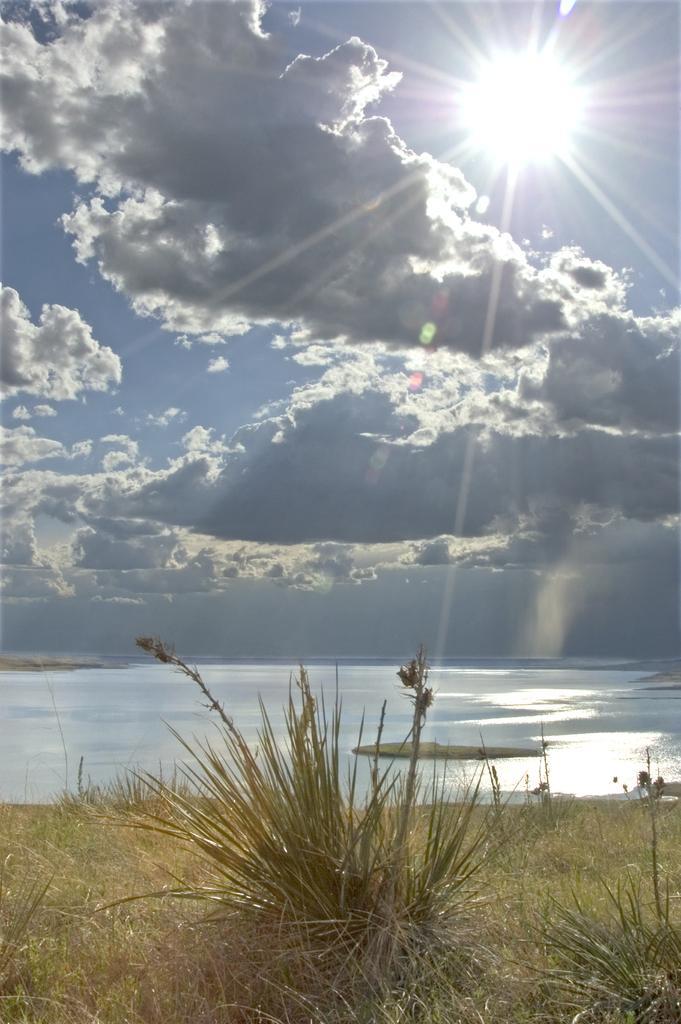Can you describe this image briefly? In this image at the bottom there is grass and some plants, and in the background there is a river and at the top there is sky and sun. 